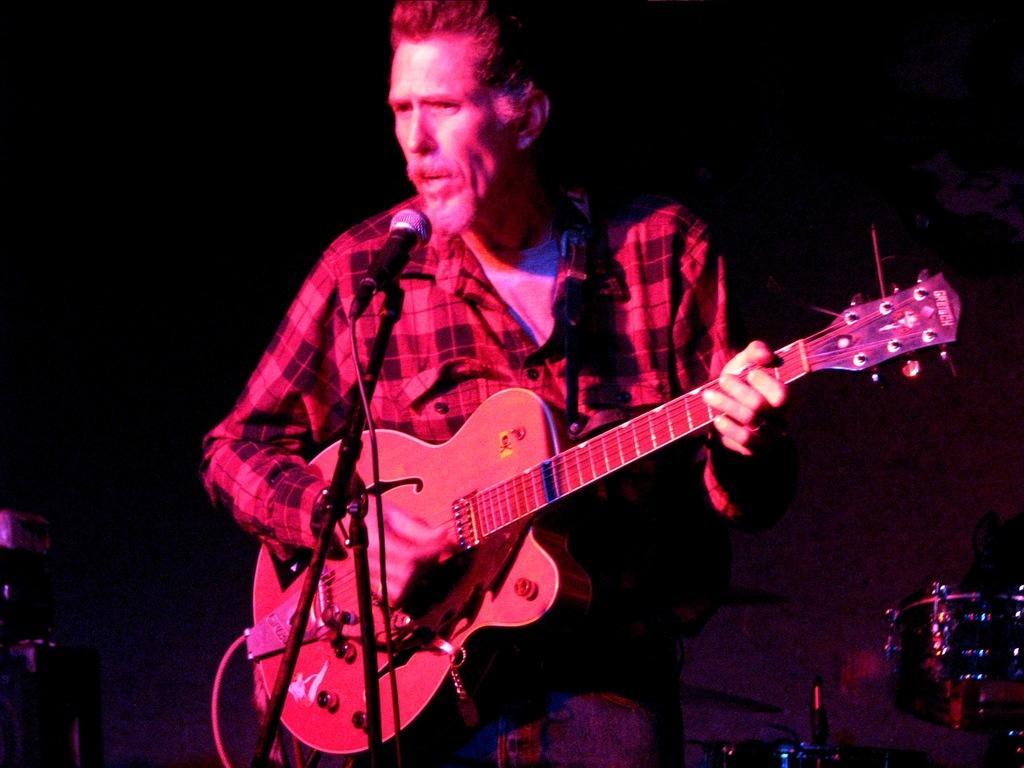How would you summarize this image in a sentence or two? This man holds guitar in-front of mic. This is an musical instrument. 